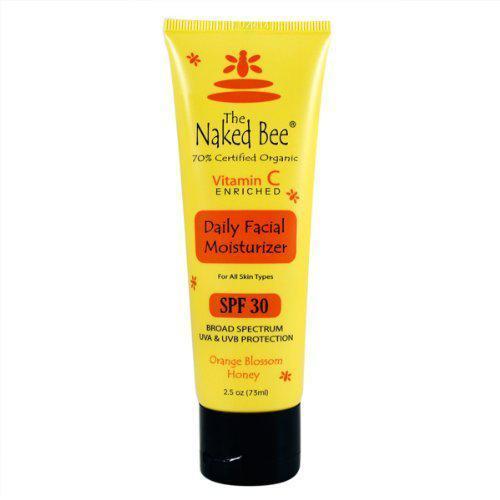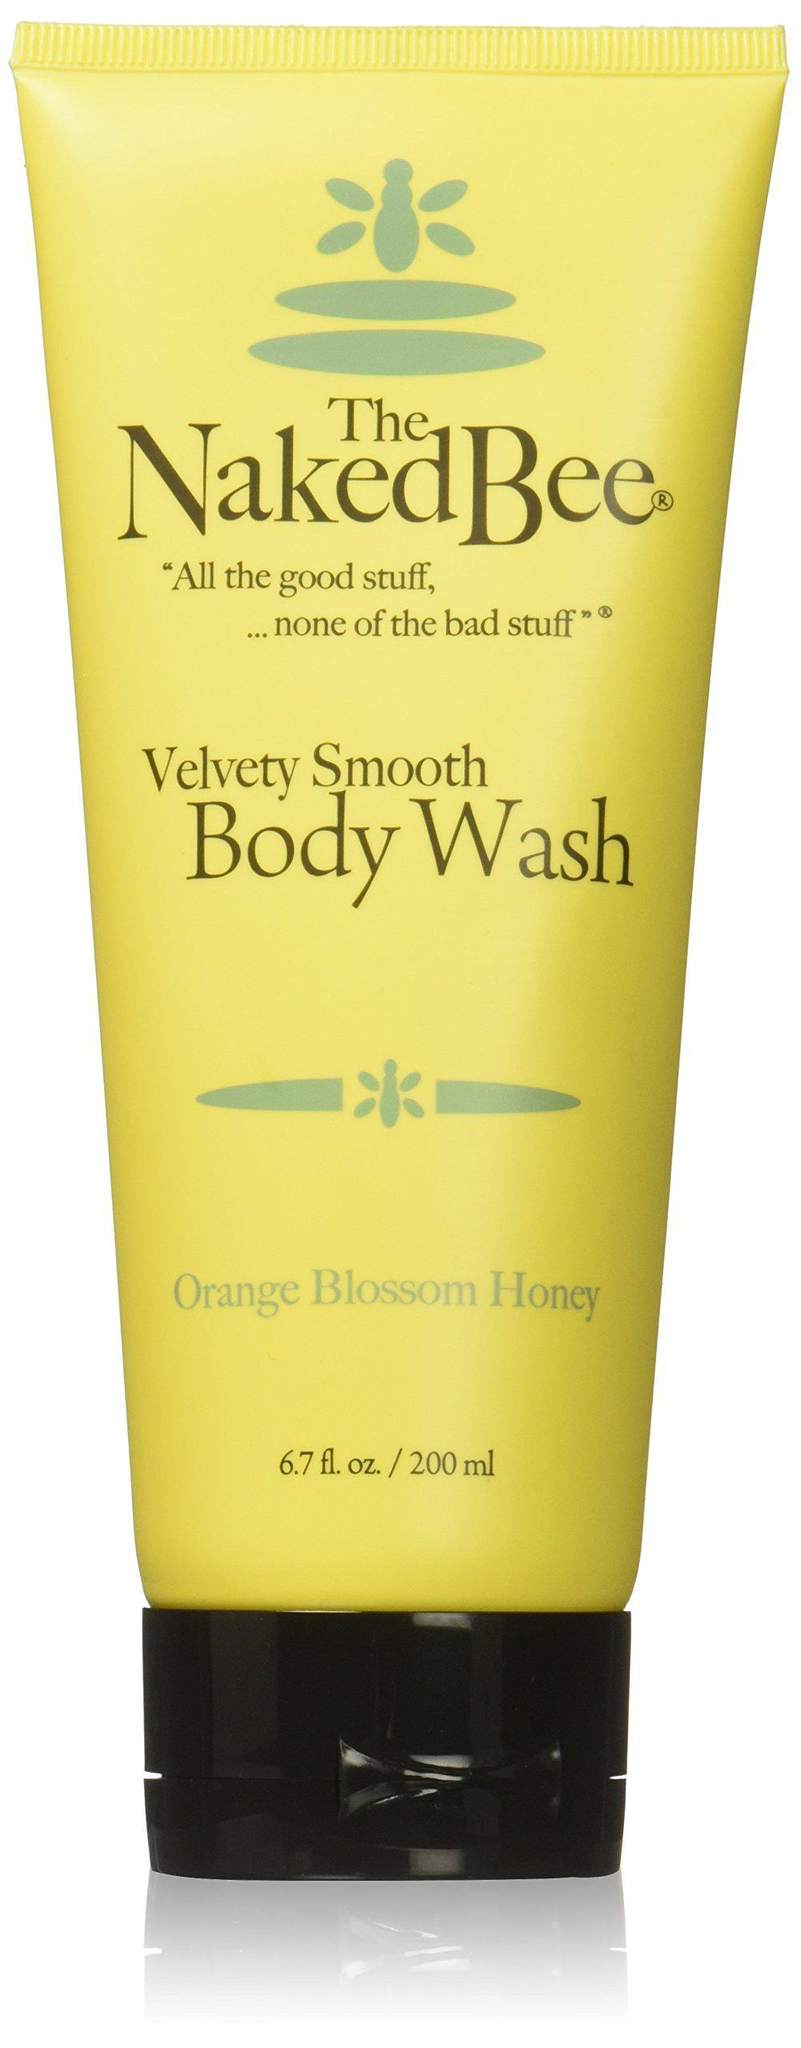The first image is the image on the left, the second image is the image on the right. For the images shown, is this caption "The left and right image contains a total of four squeeze bottles and at least one chapstick." true? Answer yes or no. No. The first image is the image on the left, the second image is the image on the right. Considering the images on both sides, is "Each image includes yellow tubes that stand on flat black flip-top caps, but only the right image includes a dark brown bottle with a black pump top." valid? Answer yes or no. No. 